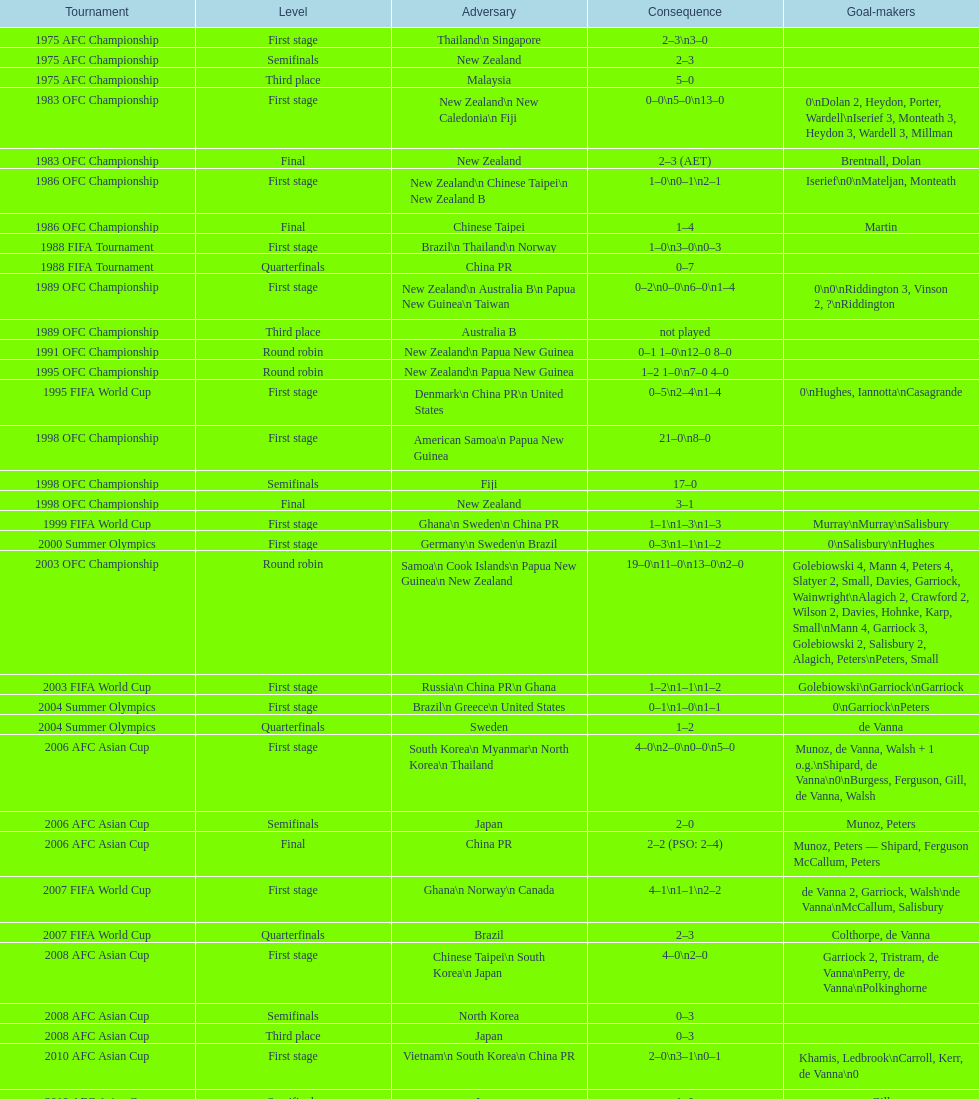Who was this team's next opponent after facing new zealand in the first stage of the 1986 ofc championship? Chinese Taipei. 